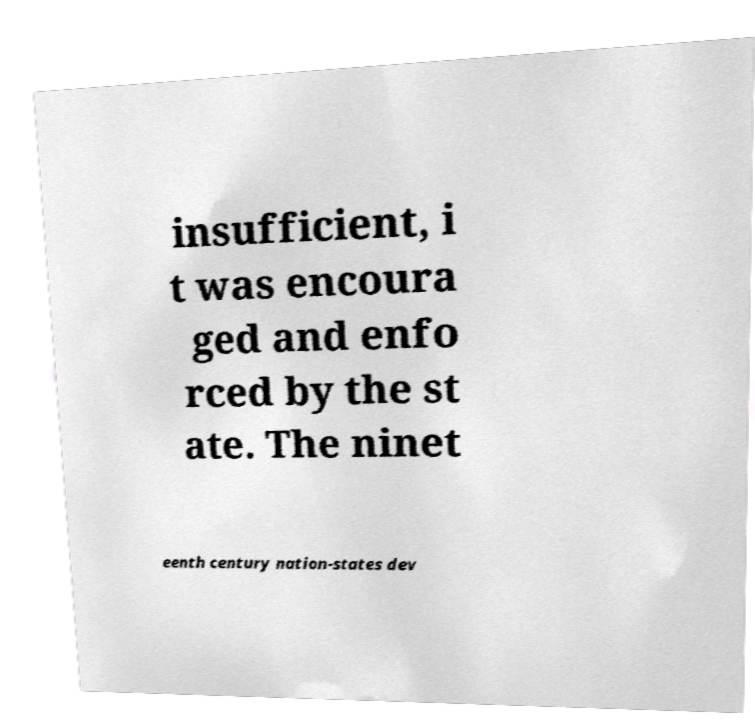Can you read and provide the text displayed in the image?This photo seems to have some interesting text. Can you extract and type it out for me? insufficient, i t was encoura ged and enfo rced by the st ate. The ninet eenth century nation-states dev 